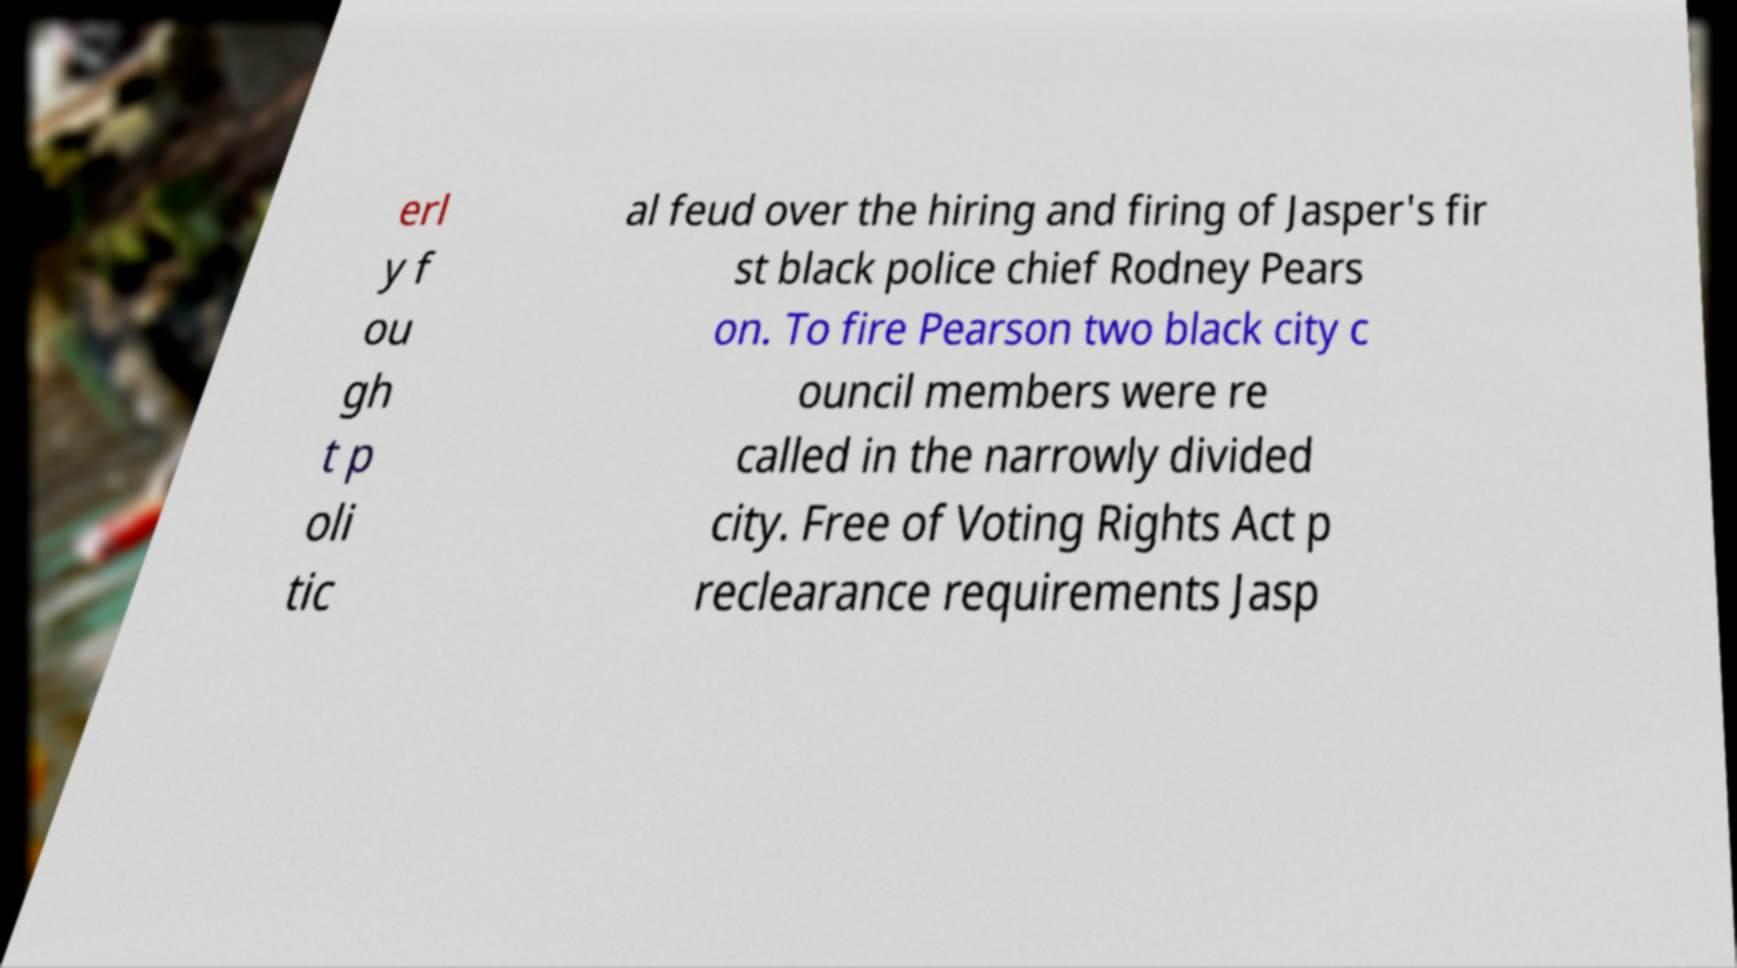What messages or text are displayed in this image? I need them in a readable, typed format. erl y f ou gh t p oli tic al feud over the hiring and firing of Jasper's fir st black police chief Rodney Pears on. To fire Pearson two black city c ouncil members were re called in the narrowly divided city. Free of Voting Rights Act p reclearance requirements Jasp 